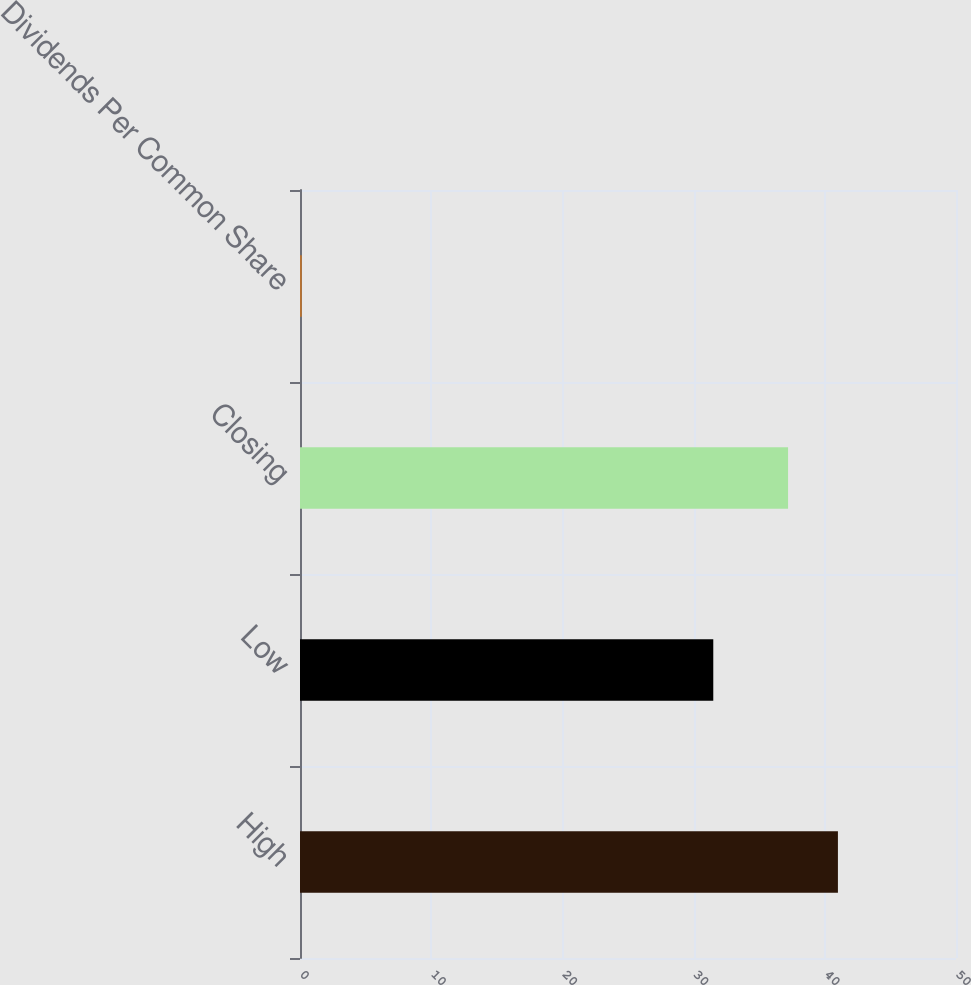Convert chart. <chart><loc_0><loc_0><loc_500><loc_500><bar_chart><fcel>High<fcel>Low<fcel>Closing<fcel>Dividends Per Common Share<nl><fcel>41<fcel>31.5<fcel>37.2<fcel>0.14<nl></chart> 